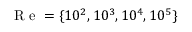Convert formula to latex. <formula><loc_0><loc_0><loc_500><loc_500>R e = \{ 1 0 ^ { 2 } , 1 0 ^ { 3 } , 1 0 ^ { 4 } , 1 0 ^ { 5 } \}</formula> 